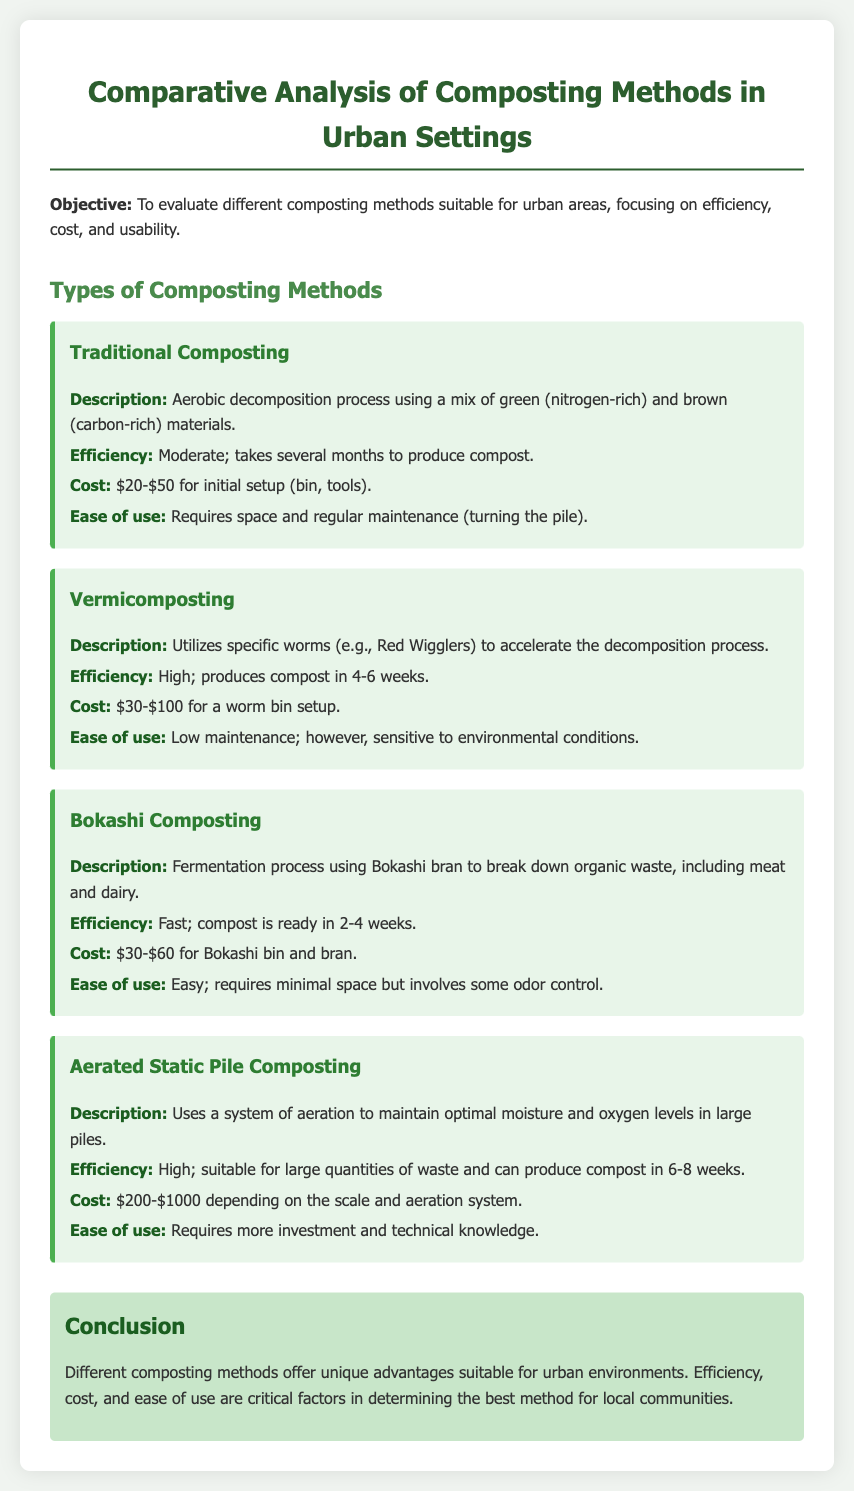What are the three factors evaluated in the analysis? The document specifically focuses on efficiency, cost, and usability of composting methods.
Answer: efficiency, cost, usability How long does it take for traditional composting to produce compost? The document states that traditional composting takes several months to produce compost.
Answer: several months What is the cost range for vermicomposting setup? The document provides cost information indicating that vermicomposting setup ranges from $30 to $100.
Answer: $30-$100 Which composting method is described as using a fermentation process? The document describes Bokashi composting as a fermentation process using Bokashi bran.
Answer: Bokashi composting What is the efficiency of Aerated Static Pile Composting? The document states that Aerated Static Pile Composting is highly efficient, suitable for large quantities, and can produce compost in 6-8 weeks.
Answer: High What special consideration is mentioned for vermicomposting? The document notes that vermicomposting is sensitive to environmental conditions, which is a specific consideration for its use.
Answer: sensitive to environmental conditions What is the efficiency classification of Bokashi composting? The document classifies Bokashi composting as fast, indicating its efficiency.
Answer: Fast How much could one potentially spend on a traditional composting setup? The document gives a cost range for a traditional composting setup from $20 to $50.
Answer: $20-$50 